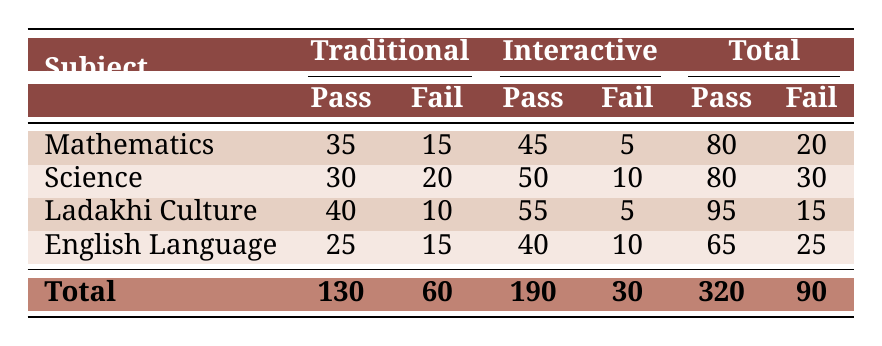What is the total number of students passing in Mathematics using the Traditional method? From the table, the value for students passing in Mathematics with the Traditional method is 35.
Answer: 35 What is the total number of students failing in Science using the Interactive method? From the table, the value for students failing in Science with the Interactive method is 10.
Answer: 10 Which subject had the highest number of students passing with the Interactive method? In the table, comparing the passing numbers for Interactive method: Mathematics (45), Science (50), Ladakhi Culture (55), and English Language (40). The highest is for Ladakhi Culture with 55 students passing.
Answer: Ladakhi Culture How many more students passed in Ladakhi Culture with the Interactive method compared to the Traditional method? The number of students passing Ladakhi Culture with the Interactive method is 55. In the Traditional method, it is 40. The difference is 55 - 40 = 15.
Answer: 15 Is it true that more students passed in the Interactive method for Mathematics than in the Traditional method? The number of students passing in Mathematics using the Interactive method is 45, while those passing using the Traditional method is 35. Since 45 is greater than 35, the statement is true.
Answer: Yes What is the ratio of students passing to students failing for the English Language in the Traditional method? For English Language using the Traditional method, there are 25 students passing and 15 failing. The ratio is 25:15, which simplifies to 5:3.
Answer: 5:3 What is the combined total of students passing across all subjects using the Interactive method? Looking at the table for Interactive method: Mathematics (45), Science (50), Ladakhi Culture (55), and English Language (40). Adding these gives 45 + 50 + 55 + 40 = 190.
Answer: 190 Which subject has the lowest total number of students failing? By comparing the failing data from the table: Mathematics (15), Science (20), Ladakhi Culture (5), and English Language (10), the lowest failing total is for Ladakhi Culture with 5 students.
Answer: Ladakhi Culture What percentage of students passed in Science using the Traditional method? The total students (passing + failing) in Science using the Traditional method is 30 (passing) + 20 (failing) = 50. The percentage passing is (30/50) * 100 = 60%.
Answer: 60% 